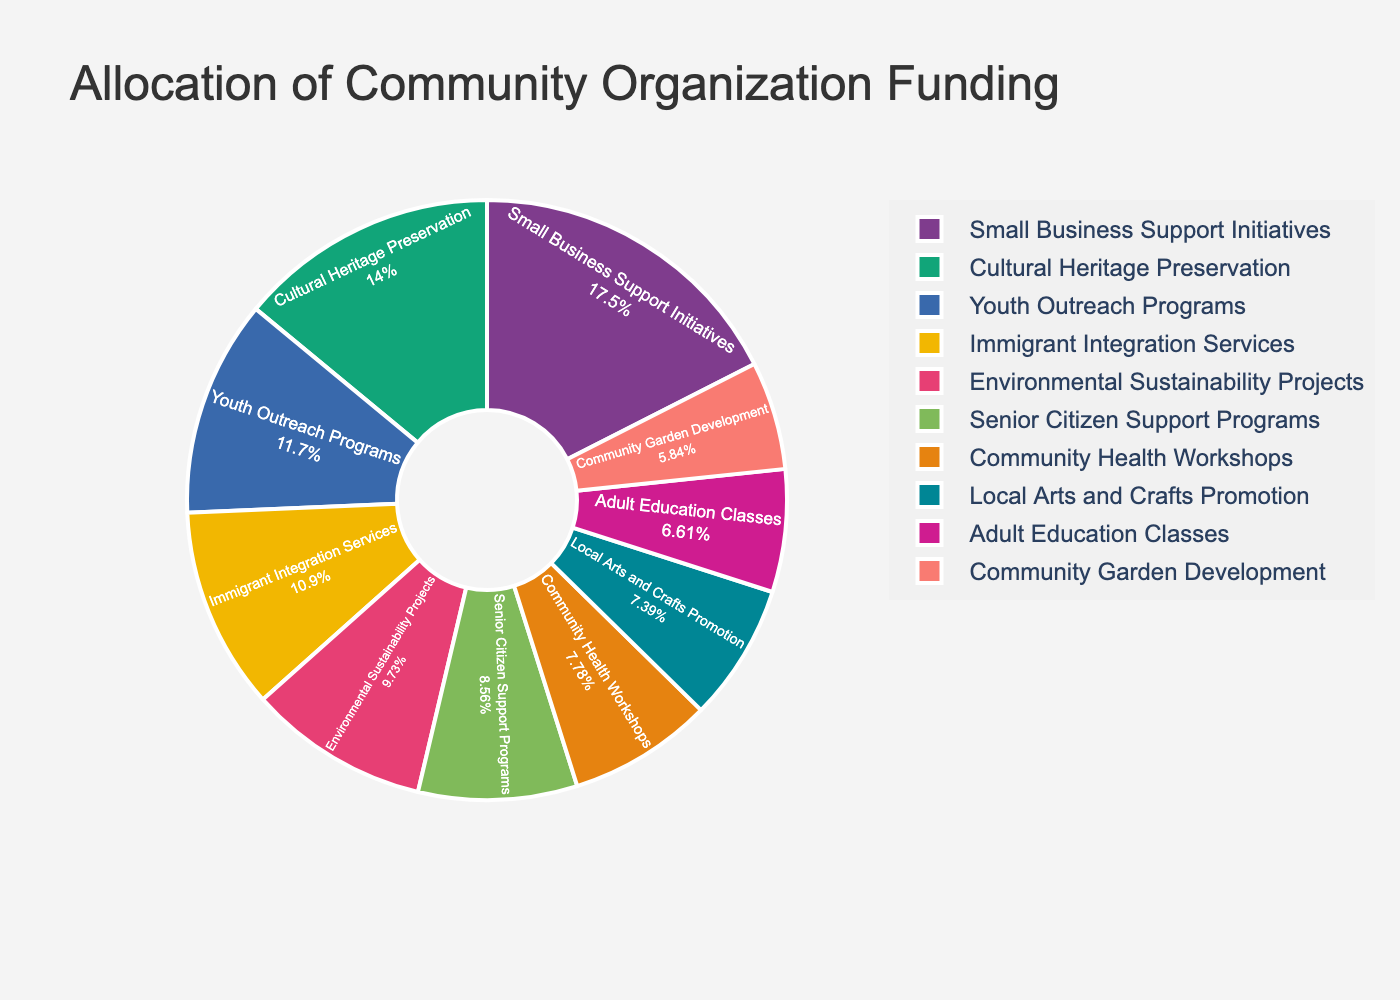Which project category receives the highest funding allocation? The pie chart shows the proportion and allocation amounts for each project category. The slice representing "Small Business Support Initiatives" is the largest, with a funding allocation of £22,500.
Answer: Small Business Support Initiatives Which project category receives the lowest funding allocation? Observing the pie chart, the smallest slice corresponds to "Community Garden Development," which has the lowest funding allocation of £7,500.
Answer: Community Garden Development What is the total funding allocation for "Youth Outreach Programs" and "Immigrant Integration Services"? The pie chart shows the funding allocation for each category. Adding the amounts for "Youth Outreach Programs" (£15,000) and "Immigrant Integration Services" (£14,000) results in £15,000 + £14,000 = £29,000.
Answer: £29,000 How does the funding for "Senior Citizen Support Programs" compare to "Community Health Workshops"? By comparing the slices on the pie chart, we see that "Community Health Workshops" receive £10,000, whereas "Senior Citizen Support Programs" get £11,000. Therefore, "Senior Citizen Support Programs" receive £1,000 more than "Community Health Workshops."
Answer: £1,000 more Identify the combined funding of categories receiving between £9,000 and £12,000. The pie chart shows the allocations, and the categories within the specified range are "Local Arts and Crafts Promotion" (£9,500), "Senior Citizen Support Programs" (£11,000), and "Community Health Workshops" (£10,000). The combined funding is £9,500 + £11,000 + £10,000 = £30,500.
Answer: £30,500 Which category occupies a larger portion of the pie chart, "Environmental Sustainability Projects" or "Adult Education Classes"? The chart slices labeled "Environmental Sustainability Projects" and "Adult Education Classes" indicate their funding allocations, £12,500 and £8,500, respectively. The larger funding means "Environmental Sustainability Projects" occupies the larger portion.
Answer: Environmental Sustainability Projects What’s the difference in funding allocation between "Cultural Heritage Preservation" and "Local Arts and Crafts Promotion"? From the pie chart, we see that "Cultural Heritage Preservation" receives £18,000 and "Local Arts and Crafts Promotion" receives £9,500. The difference is £18,000 - £9,500 = £8,500.
Answer: £8,500 How much more funding does "Small Business Support Initiatives" receive compared to "Youth Outreach Programs"? The pie chart shows "Small Business Support Initiatives" with £22,500 and "Youth Outreach Programs" with £15,000. The additional funding for "Small Business Support Initiatives" is £22,500 - £15,000 = £7,500.
Answer: £7,500 Which category's slice of the pie chart is green, and how much funding does it receive? Observing the pie chart colors, the green slice represents "Immigrant Integration Services," which has a funding allocation of £14,000.
Answer: Immigrant Integration Services, £14,000 Is the funding allocation for "Community Garden Development" more or less than half of "Cultural Heritage Preservation"? "Cultural Heritage Preservation" receives £18,000. Half of this amount is £18,000/2 = £9,000. "Community Garden Development" receives £7,500, which is less than £9,000.
Answer: Less 